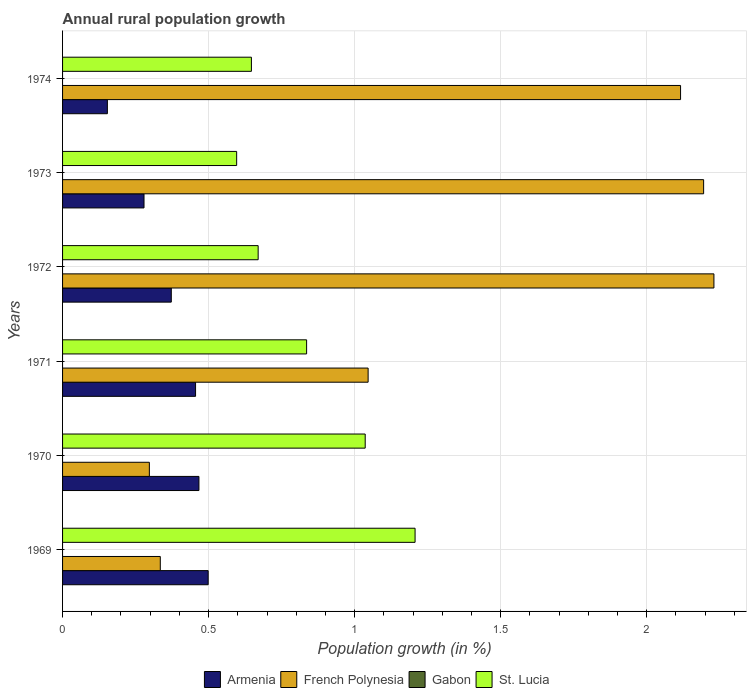How many groups of bars are there?
Provide a succinct answer. 6. Are the number of bars on each tick of the Y-axis equal?
Ensure brevity in your answer.  Yes. How many bars are there on the 3rd tick from the bottom?
Give a very brief answer. 3. What is the label of the 3rd group of bars from the top?
Give a very brief answer. 1972. In how many cases, is the number of bars for a given year not equal to the number of legend labels?
Your response must be concise. 6. What is the percentage of rural population growth in Armenia in 1970?
Give a very brief answer. 0.47. Across all years, what is the maximum percentage of rural population growth in Armenia?
Provide a succinct answer. 0.5. Across all years, what is the minimum percentage of rural population growth in French Polynesia?
Your answer should be very brief. 0.3. In which year was the percentage of rural population growth in French Polynesia maximum?
Offer a terse response. 1972. What is the total percentage of rural population growth in Armenia in the graph?
Provide a short and direct response. 2.23. What is the difference between the percentage of rural population growth in French Polynesia in 1970 and that in 1973?
Provide a short and direct response. -1.9. What is the difference between the percentage of rural population growth in French Polynesia in 1972 and the percentage of rural population growth in St. Lucia in 1974?
Make the answer very short. 1.58. What is the average percentage of rural population growth in St. Lucia per year?
Your answer should be very brief. 0.83. In the year 1969, what is the difference between the percentage of rural population growth in French Polynesia and percentage of rural population growth in St. Lucia?
Keep it short and to the point. -0.87. What is the ratio of the percentage of rural population growth in French Polynesia in 1969 to that in 1972?
Make the answer very short. 0.15. Is the difference between the percentage of rural population growth in French Polynesia in 1970 and 1973 greater than the difference between the percentage of rural population growth in St. Lucia in 1970 and 1973?
Your answer should be compact. No. What is the difference between the highest and the second highest percentage of rural population growth in French Polynesia?
Offer a terse response. 0.04. What is the difference between the highest and the lowest percentage of rural population growth in French Polynesia?
Offer a terse response. 1.93. Are all the bars in the graph horizontal?
Your answer should be very brief. Yes. What is the difference between two consecutive major ticks on the X-axis?
Keep it short and to the point. 0.5. Does the graph contain grids?
Give a very brief answer. Yes. Where does the legend appear in the graph?
Provide a succinct answer. Bottom center. What is the title of the graph?
Your answer should be very brief. Annual rural population growth. Does "Fiji" appear as one of the legend labels in the graph?
Provide a short and direct response. No. What is the label or title of the X-axis?
Make the answer very short. Population growth (in %). What is the label or title of the Y-axis?
Your answer should be compact. Years. What is the Population growth (in %) of Armenia in 1969?
Provide a short and direct response. 0.5. What is the Population growth (in %) in French Polynesia in 1969?
Provide a succinct answer. 0.33. What is the Population growth (in %) of Gabon in 1969?
Make the answer very short. 0. What is the Population growth (in %) of St. Lucia in 1969?
Keep it short and to the point. 1.21. What is the Population growth (in %) in Armenia in 1970?
Make the answer very short. 0.47. What is the Population growth (in %) in French Polynesia in 1970?
Keep it short and to the point. 0.3. What is the Population growth (in %) of St. Lucia in 1970?
Your answer should be very brief. 1.04. What is the Population growth (in %) of Armenia in 1971?
Your response must be concise. 0.46. What is the Population growth (in %) of French Polynesia in 1971?
Your answer should be compact. 1.05. What is the Population growth (in %) in St. Lucia in 1971?
Provide a succinct answer. 0.84. What is the Population growth (in %) of Armenia in 1972?
Offer a very short reply. 0.37. What is the Population growth (in %) in French Polynesia in 1972?
Provide a succinct answer. 2.23. What is the Population growth (in %) in St. Lucia in 1972?
Offer a terse response. 0.67. What is the Population growth (in %) of Armenia in 1973?
Provide a short and direct response. 0.28. What is the Population growth (in %) of French Polynesia in 1973?
Make the answer very short. 2.19. What is the Population growth (in %) of St. Lucia in 1973?
Ensure brevity in your answer.  0.6. What is the Population growth (in %) in Armenia in 1974?
Provide a succinct answer. 0.15. What is the Population growth (in %) in French Polynesia in 1974?
Give a very brief answer. 2.12. What is the Population growth (in %) of St. Lucia in 1974?
Make the answer very short. 0.65. Across all years, what is the maximum Population growth (in %) in Armenia?
Provide a short and direct response. 0.5. Across all years, what is the maximum Population growth (in %) of French Polynesia?
Provide a succinct answer. 2.23. Across all years, what is the maximum Population growth (in %) of St. Lucia?
Give a very brief answer. 1.21. Across all years, what is the minimum Population growth (in %) in Armenia?
Your answer should be very brief. 0.15. Across all years, what is the minimum Population growth (in %) in French Polynesia?
Offer a very short reply. 0.3. Across all years, what is the minimum Population growth (in %) in St. Lucia?
Your answer should be very brief. 0.6. What is the total Population growth (in %) in Armenia in the graph?
Your response must be concise. 2.23. What is the total Population growth (in %) in French Polynesia in the graph?
Your answer should be compact. 8.22. What is the total Population growth (in %) of St. Lucia in the graph?
Your answer should be compact. 4.99. What is the difference between the Population growth (in %) in Armenia in 1969 and that in 1970?
Ensure brevity in your answer.  0.03. What is the difference between the Population growth (in %) of French Polynesia in 1969 and that in 1970?
Make the answer very short. 0.04. What is the difference between the Population growth (in %) of St. Lucia in 1969 and that in 1970?
Offer a very short reply. 0.17. What is the difference between the Population growth (in %) in Armenia in 1969 and that in 1971?
Make the answer very short. 0.04. What is the difference between the Population growth (in %) of French Polynesia in 1969 and that in 1971?
Offer a very short reply. -0.71. What is the difference between the Population growth (in %) in St. Lucia in 1969 and that in 1971?
Give a very brief answer. 0.37. What is the difference between the Population growth (in %) in Armenia in 1969 and that in 1972?
Provide a succinct answer. 0.13. What is the difference between the Population growth (in %) of French Polynesia in 1969 and that in 1972?
Provide a succinct answer. -1.9. What is the difference between the Population growth (in %) of St. Lucia in 1969 and that in 1972?
Give a very brief answer. 0.54. What is the difference between the Population growth (in %) of Armenia in 1969 and that in 1973?
Your response must be concise. 0.22. What is the difference between the Population growth (in %) in French Polynesia in 1969 and that in 1973?
Make the answer very short. -1.86. What is the difference between the Population growth (in %) of St. Lucia in 1969 and that in 1973?
Ensure brevity in your answer.  0.61. What is the difference between the Population growth (in %) of Armenia in 1969 and that in 1974?
Your answer should be very brief. 0.35. What is the difference between the Population growth (in %) of French Polynesia in 1969 and that in 1974?
Your response must be concise. -1.78. What is the difference between the Population growth (in %) of St. Lucia in 1969 and that in 1974?
Keep it short and to the point. 0.56. What is the difference between the Population growth (in %) of Armenia in 1970 and that in 1971?
Your answer should be compact. 0.01. What is the difference between the Population growth (in %) in French Polynesia in 1970 and that in 1971?
Your answer should be compact. -0.75. What is the difference between the Population growth (in %) in St. Lucia in 1970 and that in 1971?
Make the answer very short. 0.2. What is the difference between the Population growth (in %) in Armenia in 1970 and that in 1972?
Offer a very short reply. 0.09. What is the difference between the Population growth (in %) in French Polynesia in 1970 and that in 1972?
Your response must be concise. -1.93. What is the difference between the Population growth (in %) of St. Lucia in 1970 and that in 1972?
Your response must be concise. 0.37. What is the difference between the Population growth (in %) in Armenia in 1970 and that in 1973?
Your answer should be compact. 0.19. What is the difference between the Population growth (in %) of French Polynesia in 1970 and that in 1973?
Your response must be concise. -1.9. What is the difference between the Population growth (in %) in St. Lucia in 1970 and that in 1973?
Provide a succinct answer. 0.44. What is the difference between the Population growth (in %) of Armenia in 1970 and that in 1974?
Make the answer very short. 0.31. What is the difference between the Population growth (in %) of French Polynesia in 1970 and that in 1974?
Your answer should be very brief. -1.82. What is the difference between the Population growth (in %) in St. Lucia in 1970 and that in 1974?
Your answer should be very brief. 0.39. What is the difference between the Population growth (in %) in Armenia in 1971 and that in 1972?
Keep it short and to the point. 0.08. What is the difference between the Population growth (in %) in French Polynesia in 1971 and that in 1972?
Provide a short and direct response. -1.18. What is the difference between the Population growth (in %) of St. Lucia in 1971 and that in 1972?
Your answer should be compact. 0.17. What is the difference between the Population growth (in %) of Armenia in 1971 and that in 1973?
Your answer should be compact. 0.18. What is the difference between the Population growth (in %) in French Polynesia in 1971 and that in 1973?
Provide a succinct answer. -1.15. What is the difference between the Population growth (in %) of St. Lucia in 1971 and that in 1973?
Your answer should be very brief. 0.24. What is the difference between the Population growth (in %) in Armenia in 1971 and that in 1974?
Keep it short and to the point. 0.3. What is the difference between the Population growth (in %) of French Polynesia in 1971 and that in 1974?
Give a very brief answer. -1.07. What is the difference between the Population growth (in %) in St. Lucia in 1971 and that in 1974?
Keep it short and to the point. 0.19. What is the difference between the Population growth (in %) in Armenia in 1972 and that in 1973?
Offer a very short reply. 0.09. What is the difference between the Population growth (in %) of French Polynesia in 1972 and that in 1973?
Keep it short and to the point. 0.04. What is the difference between the Population growth (in %) of St. Lucia in 1972 and that in 1973?
Ensure brevity in your answer.  0.07. What is the difference between the Population growth (in %) of Armenia in 1972 and that in 1974?
Provide a short and direct response. 0.22. What is the difference between the Population growth (in %) in French Polynesia in 1972 and that in 1974?
Provide a short and direct response. 0.11. What is the difference between the Population growth (in %) in St. Lucia in 1972 and that in 1974?
Offer a very short reply. 0.02. What is the difference between the Population growth (in %) of Armenia in 1973 and that in 1974?
Your response must be concise. 0.13. What is the difference between the Population growth (in %) of French Polynesia in 1973 and that in 1974?
Give a very brief answer. 0.08. What is the difference between the Population growth (in %) of St. Lucia in 1973 and that in 1974?
Your answer should be compact. -0.05. What is the difference between the Population growth (in %) in Armenia in 1969 and the Population growth (in %) in French Polynesia in 1970?
Offer a very short reply. 0.2. What is the difference between the Population growth (in %) in Armenia in 1969 and the Population growth (in %) in St. Lucia in 1970?
Offer a very short reply. -0.54. What is the difference between the Population growth (in %) of French Polynesia in 1969 and the Population growth (in %) of St. Lucia in 1970?
Your response must be concise. -0.7. What is the difference between the Population growth (in %) in Armenia in 1969 and the Population growth (in %) in French Polynesia in 1971?
Give a very brief answer. -0.55. What is the difference between the Population growth (in %) in Armenia in 1969 and the Population growth (in %) in St. Lucia in 1971?
Keep it short and to the point. -0.34. What is the difference between the Population growth (in %) of French Polynesia in 1969 and the Population growth (in %) of St. Lucia in 1971?
Keep it short and to the point. -0.5. What is the difference between the Population growth (in %) of Armenia in 1969 and the Population growth (in %) of French Polynesia in 1972?
Provide a short and direct response. -1.73. What is the difference between the Population growth (in %) in Armenia in 1969 and the Population growth (in %) in St. Lucia in 1972?
Your answer should be compact. -0.17. What is the difference between the Population growth (in %) in French Polynesia in 1969 and the Population growth (in %) in St. Lucia in 1972?
Your answer should be compact. -0.34. What is the difference between the Population growth (in %) of Armenia in 1969 and the Population growth (in %) of French Polynesia in 1973?
Offer a very short reply. -1.7. What is the difference between the Population growth (in %) in Armenia in 1969 and the Population growth (in %) in St. Lucia in 1973?
Give a very brief answer. -0.1. What is the difference between the Population growth (in %) of French Polynesia in 1969 and the Population growth (in %) of St. Lucia in 1973?
Provide a short and direct response. -0.26. What is the difference between the Population growth (in %) in Armenia in 1969 and the Population growth (in %) in French Polynesia in 1974?
Provide a short and direct response. -1.62. What is the difference between the Population growth (in %) of Armenia in 1969 and the Population growth (in %) of St. Lucia in 1974?
Keep it short and to the point. -0.15. What is the difference between the Population growth (in %) in French Polynesia in 1969 and the Population growth (in %) in St. Lucia in 1974?
Provide a succinct answer. -0.31. What is the difference between the Population growth (in %) of Armenia in 1970 and the Population growth (in %) of French Polynesia in 1971?
Provide a succinct answer. -0.58. What is the difference between the Population growth (in %) in Armenia in 1970 and the Population growth (in %) in St. Lucia in 1971?
Offer a very short reply. -0.37. What is the difference between the Population growth (in %) of French Polynesia in 1970 and the Population growth (in %) of St. Lucia in 1971?
Ensure brevity in your answer.  -0.54. What is the difference between the Population growth (in %) of Armenia in 1970 and the Population growth (in %) of French Polynesia in 1972?
Make the answer very short. -1.76. What is the difference between the Population growth (in %) in Armenia in 1970 and the Population growth (in %) in St. Lucia in 1972?
Your answer should be compact. -0.2. What is the difference between the Population growth (in %) of French Polynesia in 1970 and the Population growth (in %) of St. Lucia in 1972?
Offer a very short reply. -0.37. What is the difference between the Population growth (in %) of Armenia in 1970 and the Population growth (in %) of French Polynesia in 1973?
Ensure brevity in your answer.  -1.73. What is the difference between the Population growth (in %) of Armenia in 1970 and the Population growth (in %) of St. Lucia in 1973?
Your answer should be very brief. -0.13. What is the difference between the Population growth (in %) of French Polynesia in 1970 and the Population growth (in %) of St. Lucia in 1973?
Provide a succinct answer. -0.3. What is the difference between the Population growth (in %) in Armenia in 1970 and the Population growth (in %) in French Polynesia in 1974?
Provide a short and direct response. -1.65. What is the difference between the Population growth (in %) in Armenia in 1970 and the Population growth (in %) in St. Lucia in 1974?
Make the answer very short. -0.18. What is the difference between the Population growth (in %) of French Polynesia in 1970 and the Population growth (in %) of St. Lucia in 1974?
Your response must be concise. -0.35. What is the difference between the Population growth (in %) of Armenia in 1971 and the Population growth (in %) of French Polynesia in 1972?
Ensure brevity in your answer.  -1.77. What is the difference between the Population growth (in %) in Armenia in 1971 and the Population growth (in %) in St. Lucia in 1972?
Your response must be concise. -0.21. What is the difference between the Population growth (in %) in French Polynesia in 1971 and the Population growth (in %) in St. Lucia in 1972?
Provide a short and direct response. 0.38. What is the difference between the Population growth (in %) of Armenia in 1971 and the Population growth (in %) of French Polynesia in 1973?
Provide a short and direct response. -1.74. What is the difference between the Population growth (in %) of Armenia in 1971 and the Population growth (in %) of St. Lucia in 1973?
Your response must be concise. -0.14. What is the difference between the Population growth (in %) in French Polynesia in 1971 and the Population growth (in %) in St. Lucia in 1973?
Your answer should be very brief. 0.45. What is the difference between the Population growth (in %) of Armenia in 1971 and the Population growth (in %) of French Polynesia in 1974?
Provide a succinct answer. -1.66. What is the difference between the Population growth (in %) in Armenia in 1971 and the Population growth (in %) in St. Lucia in 1974?
Offer a very short reply. -0.19. What is the difference between the Population growth (in %) of French Polynesia in 1971 and the Population growth (in %) of St. Lucia in 1974?
Your answer should be compact. 0.4. What is the difference between the Population growth (in %) of Armenia in 1972 and the Population growth (in %) of French Polynesia in 1973?
Ensure brevity in your answer.  -1.82. What is the difference between the Population growth (in %) in Armenia in 1972 and the Population growth (in %) in St. Lucia in 1973?
Provide a short and direct response. -0.22. What is the difference between the Population growth (in %) of French Polynesia in 1972 and the Population growth (in %) of St. Lucia in 1973?
Give a very brief answer. 1.63. What is the difference between the Population growth (in %) in Armenia in 1972 and the Population growth (in %) in French Polynesia in 1974?
Your response must be concise. -1.74. What is the difference between the Population growth (in %) in Armenia in 1972 and the Population growth (in %) in St. Lucia in 1974?
Your response must be concise. -0.27. What is the difference between the Population growth (in %) in French Polynesia in 1972 and the Population growth (in %) in St. Lucia in 1974?
Provide a short and direct response. 1.58. What is the difference between the Population growth (in %) in Armenia in 1973 and the Population growth (in %) in French Polynesia in 1974?
Offer a very short reply. -1.84. What is the difference between the Population growth (in %) in Armenia in 1973 and the Population growth (in %) in St. Lucia in 1974?
Provide a succinct answer. -0.37. What is the difference between the Population growth (in %) in French Polynesia in 1973 and the Population growth (in %) in St. Lucia in 1974?
Make the answer very short. 1.55. What is the average Population growth (in %) in Armenia per year?
Make the answer very short. 0.37. What is the average Population growth (in %) in French Polynesia per year?
Offer a terse response. 1.37. What is the average Population growth (in %) of Gabon per year?
Make the answer very short. 0. What is the average Population growth (in %) in St. Lucia per year?
Offer a terse response. 0.83. In the year 1969, what is the difference between the Population growth (in %) of Armenia and Population growth (in %) of French Polynesia?
Provide a succinct answer. 0.16. In the year 1969, what is the difference between the Population growth (in %) in Armenia and Population growth (in %) in St. Lucia?
Your answer should be very brief. -0.71. In the year 1969, what is the difference between the Population growth (in %) of French Polynesia and Population growth (in %) of St. Lucia?
Provide a short and direct response. -0.87. In the year 1970, what is the difference between the Population growth (in %) of Armenia and Population growth (in %) of French Polynesia?
Your answer should be very brief. 0.17. In the year 1970, what is the difference between the Population growth (in %) of Armenia and Population growth (in %) of St. Lucia?
Give a very brief answer. -0.57. In the year 1970, what is the difference between the Population growth (in %) of French Polynesia and Population growth (in %) of St. Lucia?
Give a very brief answer. -0.74. In the year 1971, what is the difference between the Population growth (in %) in Armenia and Population growth (in %) in French Polynesia?
Make the answer very short. -0.59. In the year 1971, what is the difference between the Population growth (in %) in Armenia and Population growth (in %) in St. Lucia?
Give a very brief answer. -0.38. In the year 1971, what is the difference between the Population growth (in %) in French Polynesia and Population growth (in %) in St. Lucia?
Ensure brevity in your answer.  0.21. In the year 1972, what is the difference between the Population growth (in %) in Armenia and Population growth (in %) in French Polynesia?
Your answer should be compact. -1.86. In the year 1972, what is the difference between the Population growth (in %) of Armenia and Population growth (in %) of St. Lucia?
Provide a short and direct response. -0.3. In the year 1972, what is the difference between the Population growth (in %) in French Polynesia and Population growth (in %) in St. Lucia?
Provide a short and direct response. 1.56. In the year 1973, what is the difference between the Population growth (in %) of Armenia and Population growth (in %) of French Polynesia?
Ensure brevity in your answer.  -1.92. In the year 1973, what is the difference between the Population growth (in %) in Armenia and Population growth (in %) in St. Lucia?
Your response must be concise. -0.32. In the year 1973, what is the difference between the Population growth (in %) of French Polynesia and Population growth (in %) of St. Lucia?
Provide a short and direct response. 1.6. In the year 1974, what is the difference between the Population growth (in %) in Armenia and Population growth (in %) in French Polynesia?
Your response must be concise. -1.96. In the year 1974, what is the difference between the Population growth (in %) of Armenia and Population growth (in %) of St. Lucia?
Your answer should be compact. -0.49. In the year 1974, what is the difference between the Population growth (in %) of French Polynesia and Population growth (in %) of St. Lucia?
Provide a succinct answer. 1.47. What is the ratio of the Population growth (in %) of Armenia in 1969 to that in 1970?
Your answer should be compact. 1.07. What is the ratio of the Population growth (in %) of French Polynesia in 1969 to that in 1970?
Provide a succinct answer. 1.13. What is the ratio of the Population growth (in %) of St. Lucia in 1969 to that in 1970?
Give a very brief answer. 1.16. What is the ratio of the Population growth (in %) in Armenia in 1969 to that in 1971?
Your answer should be compact. 1.09. What is the ratio of the Population growth (in %) in French Polynesia in 1969 to that in 1971?
Provide a short and direct response. 0.32. What is the ratio of the Population growth (in %) in St. Lucia in 1969 to that in 1971?
Your answer should be very brief. 1.44. What is the ratio of the Population growth (in %) in Armenia in 1969 to that in 1972?
Give a very brief answer. 1.34. What is the ratio of the Population growth (in %) in St. Lucia in 1969 to that in 1972?
Your answer should be very brief. 1.8. What is the ratio of the Population growth (in %) in Armenia in 1969 to that in 1973?
Your answer should be compact. 1.79. What is the ratio of the Population growth (in %) of French Polynesia in 1969 to that in 1973?
Give a very brief answer. 0.15. What is the ratio of the Population growth (in %) of St. Lucia in 1969 to that in 1973?
Provide a succinct answer. 2.02. What is the ratio of the Population growth (in %) in Armenia in 1969 to that in 1974?
Give a very brief answer. 3.25. What is the ratio of the Population growth (in %) in French Polynesia in 1969 to that in 1974?
Offer a terse response. 0.16. What is the ratio of the Population growth (in %) in St. Lucia in 1969 to that in 1974?
Provide a succinct answer. 1.87. What is the ratio of the Population growth (in %) of Armenia in 1970 to that in 1971?
Ensure brevity in your answer.  1.03. What is the ratio of the Population growth (in %) in French Polynesia in 1970 to that in 1971?
Keep it short and to the point. 0.28. What is the ratio of the Population growth (in %) of St. Lucia in 1970 to that in 1971?
Offer a terse response. 1.24. What is the ratio of the Population growth (in %) in Armenia in 1970 to that in 1972?
Give a very brief answer. 1.25. What is the ratio of the Population growth (in %) of French Polynesia in 1970 to that in 1972?
Keep it short and to the point. 0.13. What is the ratio of the Population growth (in %) in St. Lucia in 1970 to that in 1972?
Keep it short and to the point. 1.55. What is the ratio of the Population growth (in %) in Armenia in 1970 to that in 1973?
Give a very brief answer. 1.67. What is the ratio of the Population growth (in %) in French Polynesia in 1970 to that in 1973?
Your answer should be compact. 0.14. What is the ratio of the Population growth (in %) of St. Lucia in 1970 to that in 1973?
Your answer should be very brief. 1.74. What is the ratio of the Population growth (in %) in Armenia in 1970 to that in 1974?
Your answer should be very brief. 3.04. What is the ratio of the Population growth (in %) of French Polynesia in 1970 to that in 1974?
Offer a very short reply. 0.14. What is the ratio of the Population growth (in %) in St. Lucia in 1970 to that in 1974?
Ensure brevity in your answer.  1.6. What is the ratio of the Population growth (in %) of Armenia in 1971 to that in 1972?
Give a very brief answer. 1.22. What is the ratio of the Population growth (in %) in French Polynesia in 1971 to that in 1972?
Make the answer very short. 0.47. What is the ratio of the Population growth (in %) in St. Lucia in 1971 to that in 1972?
Keep it short and to the point. 1.25. What is the ratio of the Population growth (in %) in Armenia in 1971 to that in 1973?
Ensure brevity in your answer.  1.63. What is the ratio of the Population growth (in %) in French Polynesia in 1971 to that in 1973?
Your answer should be compact. 0.48. What is the ratio of the Population growth (in %) in St. Lucia in 1971 to that in 1973?
Offer a terse response. 1.4. What is the ratio of the Population growth (in %) of Armenia in 1971 to that in 1974?
Make the answer very short. 2.97. What is the ratio of the Population growth (in %) of French Polynesia in 1971 to that in 1974?
Your answer should be very brief. 0.49. What is the ratio of the Population growth (in %) of St. Lucia in 1971 to that in 1974?
Your response must be concise. 1.29. What is the ratio of the Population growth (in %) of Armenia in 1972 to that in 1973?
Provide a short and direct response. 1.33. What is the ratio of the Population growth (in %) in French Polynesia in 1972 to that in 1973?
Your answer should be very brief. 1.02. What is the ratio of the Population growth (in %) of St. Lucia in 1972 to that in 1973?
Give a very brief answer. 1.12. What is the ratio of the Population growth (in %) of Armenia in 1972 to that in 1974?
Ensure brevity in your answer.  2.43. What is the ratio of the Population growth (in %) in French Polynesia in 1972 to that in 1974?
Make the answer very short. 1.05. What is the ratio of the Population growth (in %) in St. Lucia in 1972 to that in 1974?
Ensure brevity in your answer.  1.04. What is the ratio of the Population growth (in %) of Armenia in 1973 to that in 1974?
Your response must be concise. 1.82. What is the ratio of the Population growth (in %) of French Polynesia in 1973 to that in 1974?
Make the answer very short. 1.04. What is the ratio of the Population growth (in %) of St. Lucia in 1973 to that in 1974?
Make the answer very short. 0.92. What is the difference between the highest and the second highest Population growth (in %) of Armenia?
Your answer should be very brief. 0.03. What is the difference between the highest and the second highest Population growth (in %) of French Polynesia?
Provide a short and direct response. 0.04. What is the difference between the highest and the second highest Population growth (in %) of St. Lucia?
Provide a short and direct response. 0.17. What is the difference between the highest and the lowest Population growth (in %) in Armenia?
Provide a short and direct response. 0.35. What is the difference between the highest and the lowest Population growth (in %) of French Polynesia?
Your answer should be compact. 1.93. What is the difference between the highest and the lowest Population growth (in %) of St. Lucia?
Your answer should be compact. 0.61. 